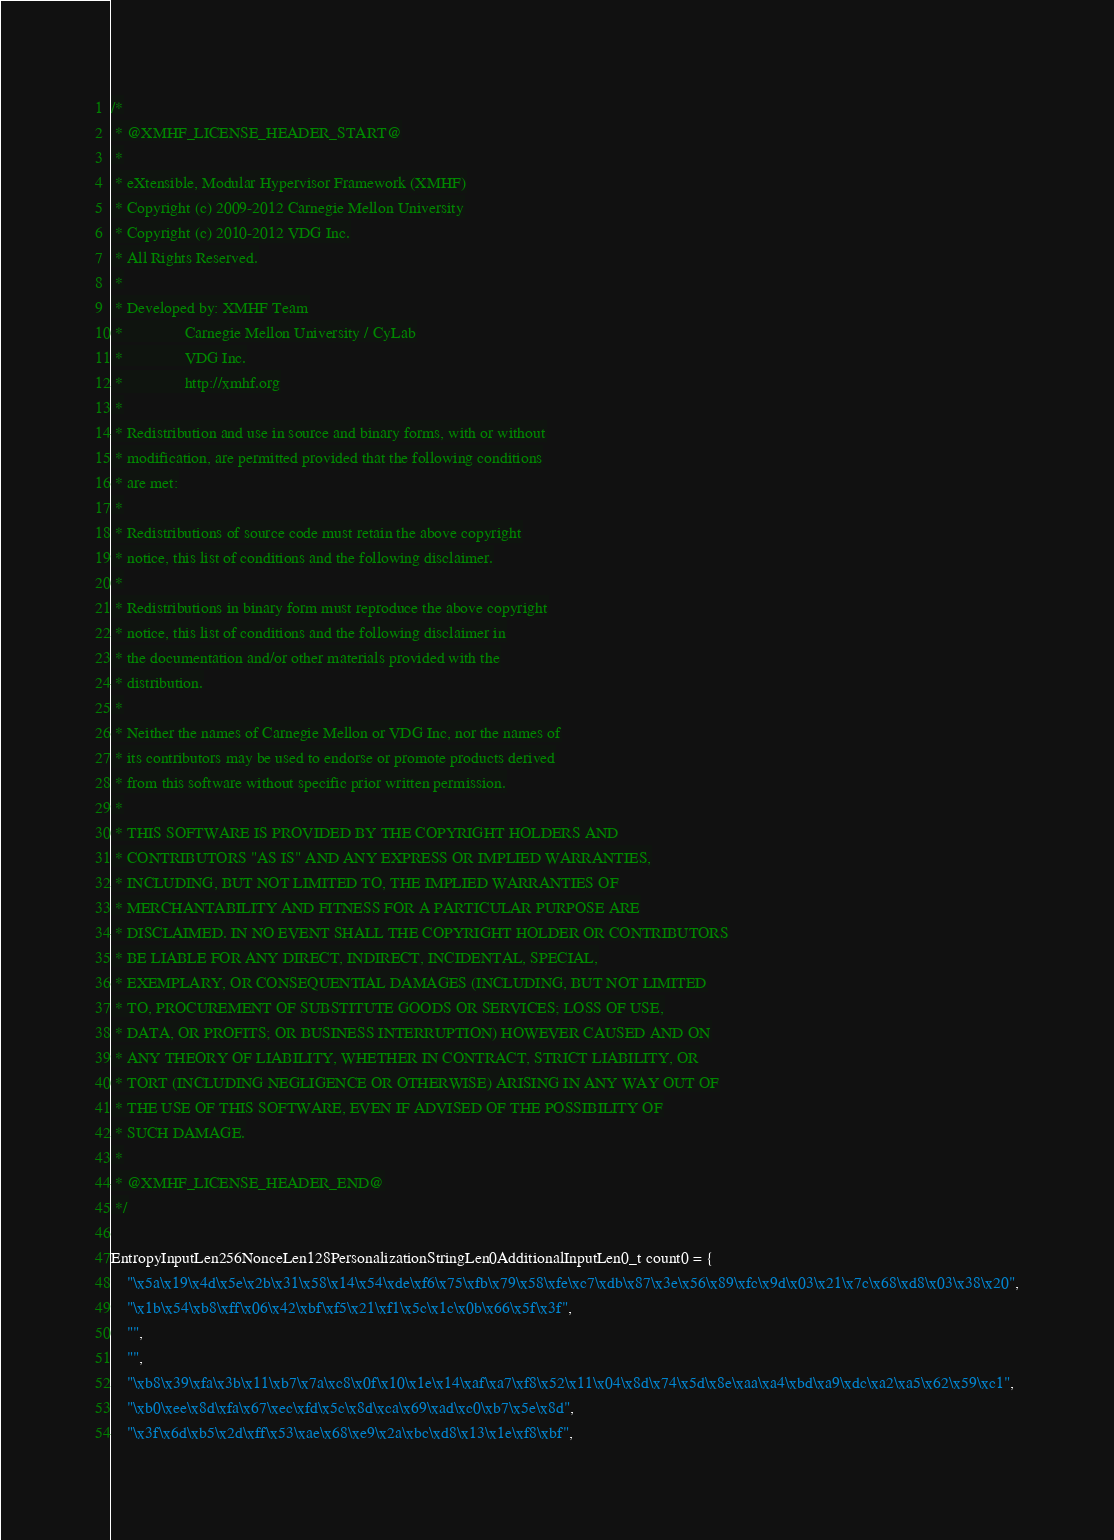<code> <loc_0><loc_0><loc_500><loc_500><_C_>/*
 * @XMHF_LICENSE_HEADER_START@
 *
 * eXtensible, Modular Hypervisor Framework (XMHF)
 * Copyright (c) 2009-2012 Carnegie Mellon University
 * Copyright (c) 2010-2012 VDG Inc.
 * All Rights Reserved.
 *
 * Developed by: XMHF Team
 *               Carnegie Mellon University / CyLab
 *               VDG Inc.
 *               http://xmhf.org
 *
 * Redistribution and use in source and binary forms, with or without
 * modification, are permitted provided that the following conditions
 * are met:
 *
 * Redistributions of source code must retain the above copyright
 * notice, this list of conditions and the following disclaimer.
 *
 * Redistributions in binary form must reproduce the above copyright
 * notice, this list of conditions and the following disclaimer in
 * the documentation and/or other materials provided with the
 * distribution.
 *
 * Neither the names of Carnegie Mellon or VDG Inc, nor the names of
 * its contributors may be used to endorse or promote products derived
 * from this software without specific prior written permission.
 *
 * THIS SOFTWARE IS PROVIDED BY THE COPYRIGHT HOLDERS AND
 * CONTRIBUTORS "AS IS" AND ANY EXPRESS OR IMPLIED WARRANTIES,
 * INCLUDING, BUT NOT LIMITED TO, THE IMPLIED WARRANTIES OF
 * MERCHANTABILITY AND FITNESS FOR A PARTICULAR PURPOSE ARE
 * DISCLAIMED. IN NO EVENT SHALL THE COPYRIGHT HOLDER OR CONTRIBUTORS
 * BE LIABLE FOR ANY DIRECT, INDIRECT, INCIDENTAL, SPECIAL,
 * EXEMPLARY, OR CONSEQUENTIAL DAMAGES (INCLUDING, BUT NOT LIMITED
 * TO, PROCUREMENT OF SUBSTITUTE GOODS OR SERVICES; LOSS OF USE,
 * DATA, OR PROFITS; OR BUSINESS INTERRUPTION) HOWEVER CAUSED AND ON
 * ANY THEORY OF LIABILITY, WHETHER IN CONTRACT, STRICT LIABILITY, OR
 * TORT (INCLUDING NEGLIGENCE OR OTHERWISE) ARISING IN ANY WAY OUT OF
 * THE USE OF THIS SOFTWARE, EVEN IF ADVISED OF THE POSSIBILITY OF
 * SUCH DAMAGE.
 *
 * @XMHF_LICENSE_HEADER_END@
 */

EntropyInputLen256NonceLen128PersonalizationStringLen0AdditionalInputLen0_t count0 = {
    "\x5a\x19\x4d\x5e\x2b\x31\x58\x14\x54\xde\xf6\x75\xfb\x79\x58\xfe\xc7\xdb\x87\x3e\x56\x89\xfc\x9d\x03\x21\x7c\x68\xd8\x03\x38\x20",
    "\x1b\x54\xb8\xff\x06\x42\xbf\xf5\x21\xf1\x5c\x1c\x0b\x66\x5f\x3f",
    "",
    "",
    "\xb8\x39\xfa\x3b\x11\xb7\x7a\xc8\x0f\x10\x1e\x14\xaf\xa7\xf8\x52\x11\x04\x8d\x74\x5d\x8e\xaa\xa4\xbd\xa9\xdc\xa2\xa5\x62\x59\xc1",
    "\xb0\xee\x8d\xfa\x67\xec\xfd\x5c\x8d\xca\x69\xad\xc0\xb7\x5e\x8d",
    "\x3f\x6d\xb5\x2d\xff\x53\xae\x68\xe9\x2a\xbc\xd8\x13\x1e\xf8\xbf",</code> 